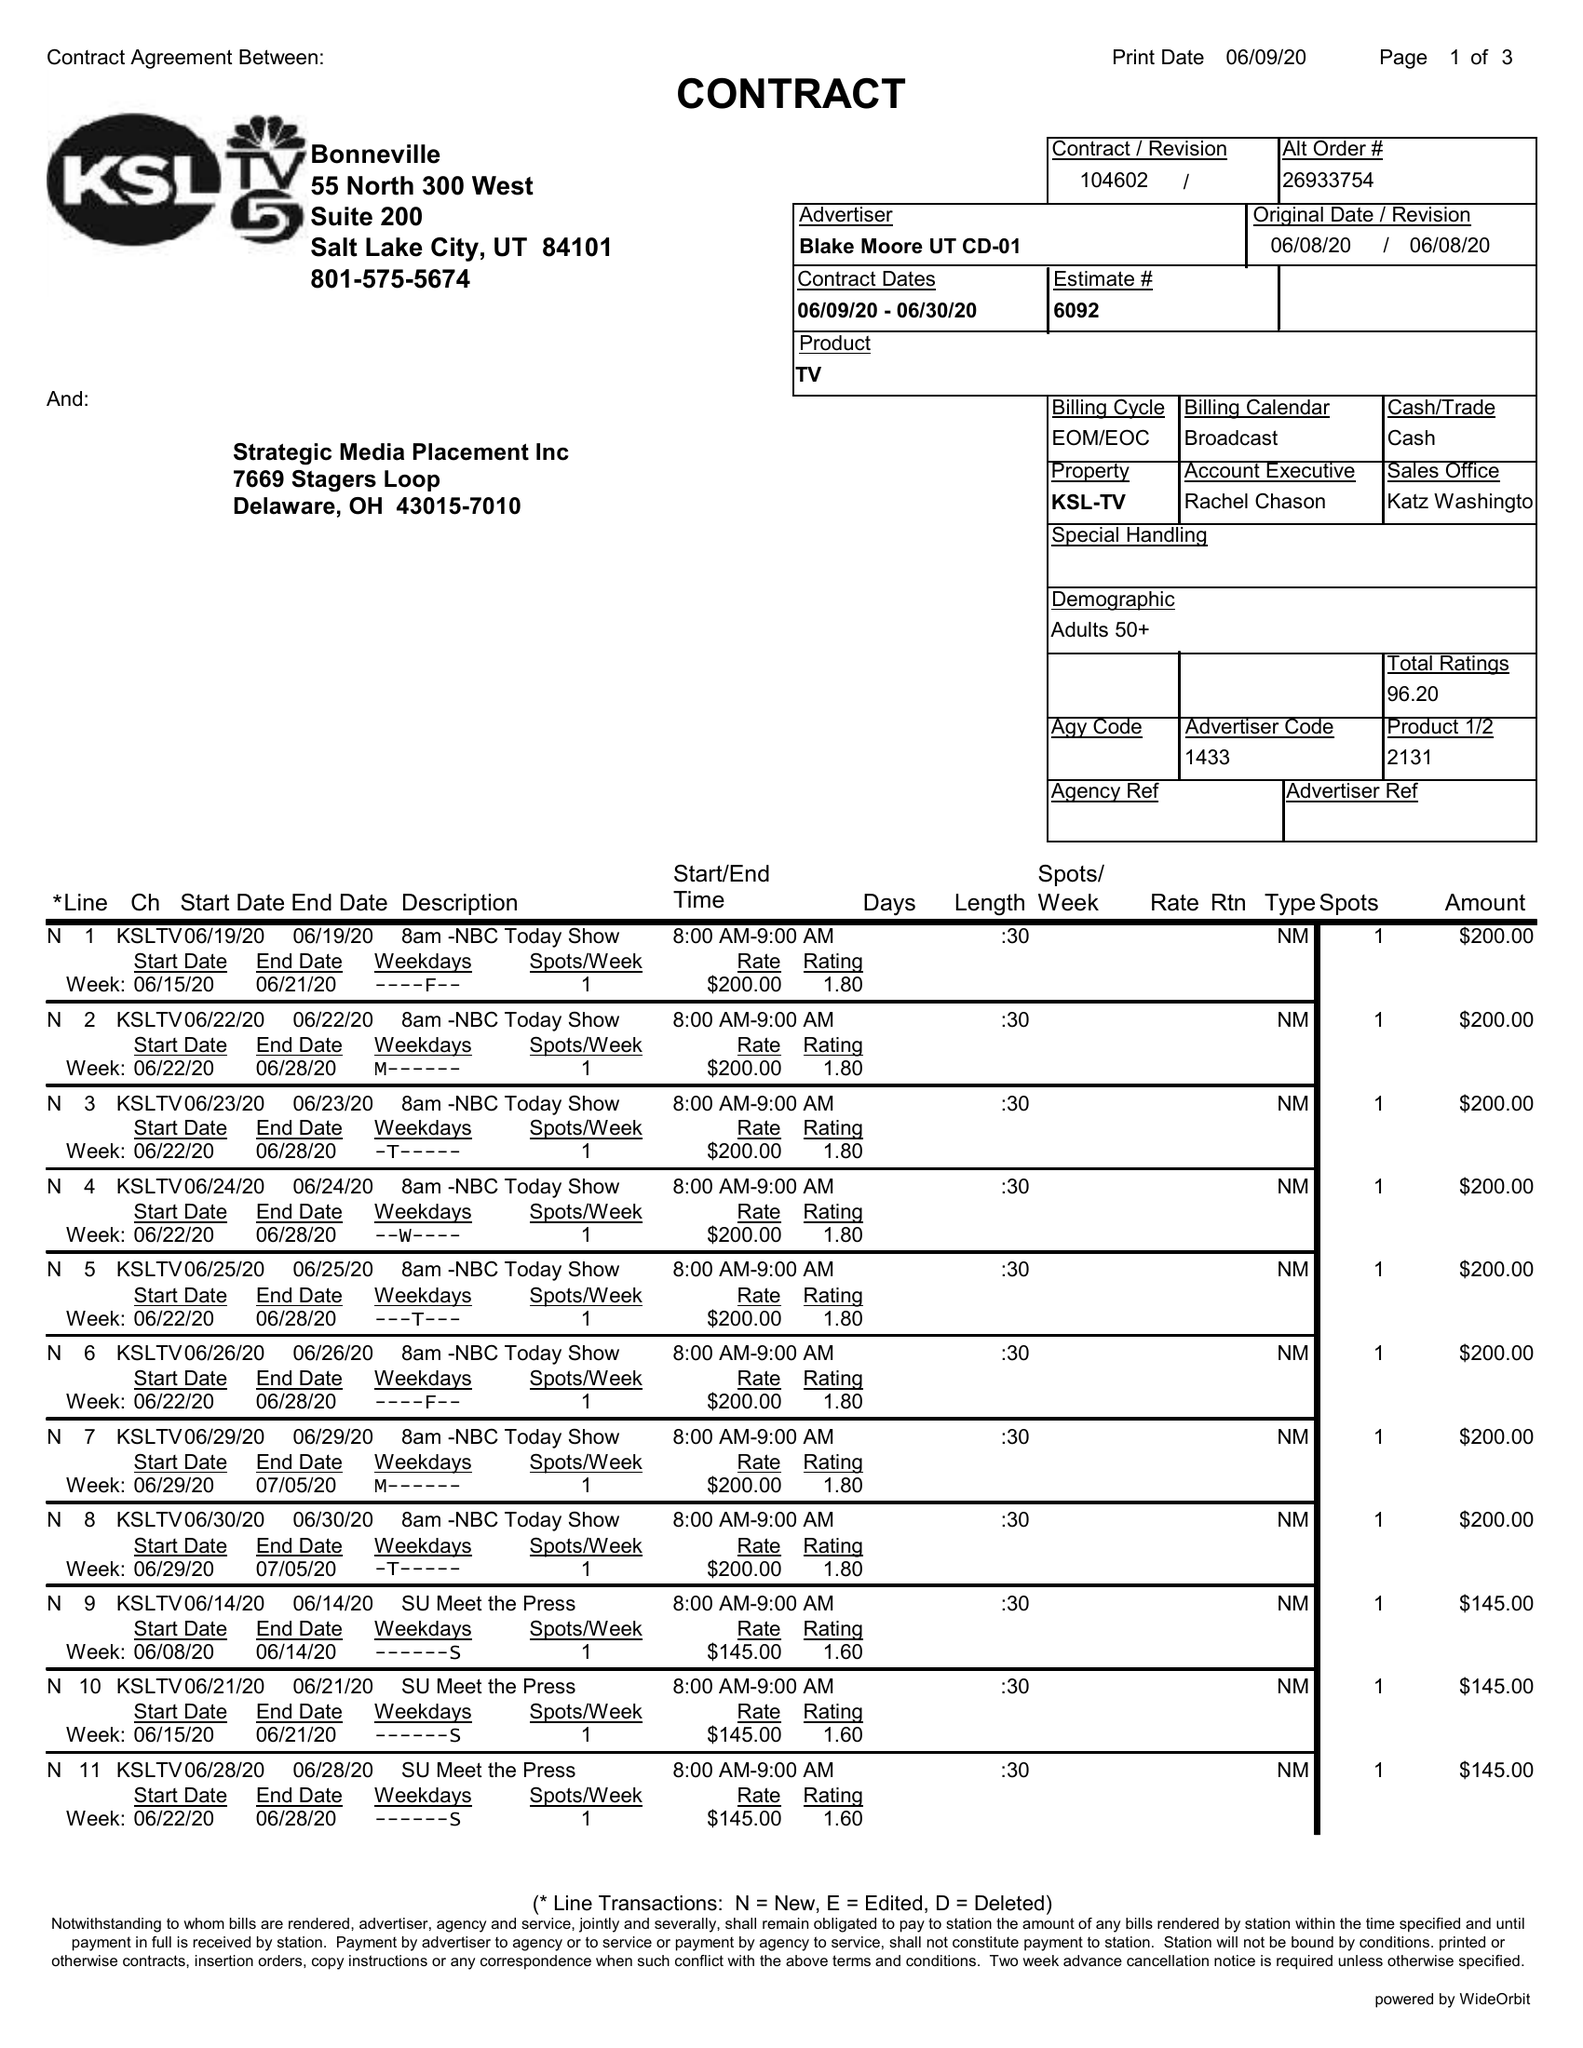What is the value for the flight_to?
Answer the question using a single word or phrase. 06/30/20 